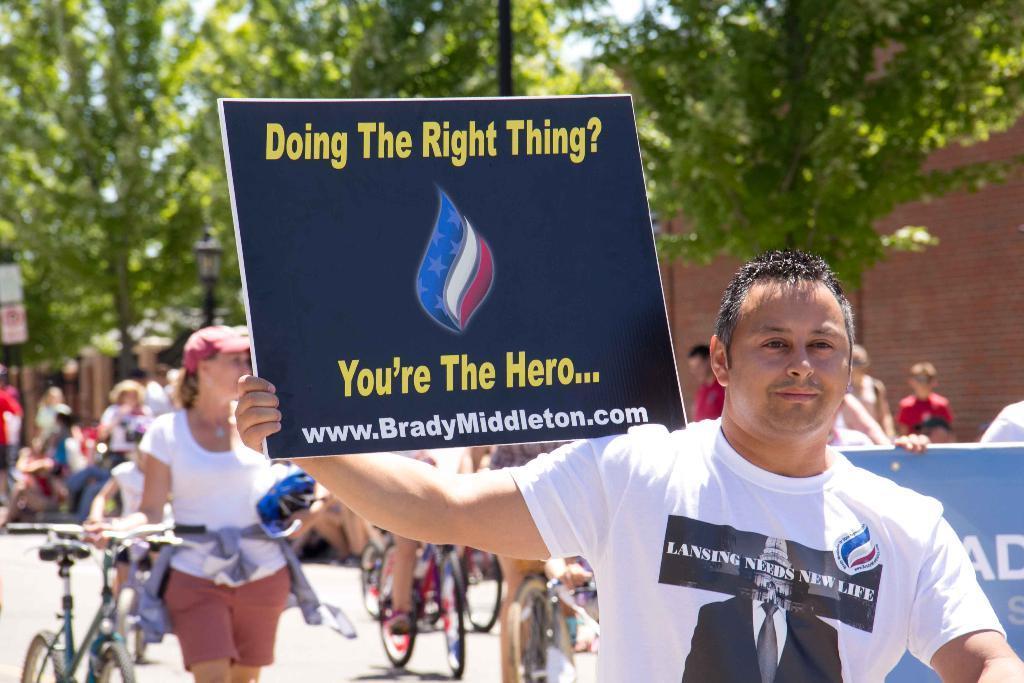How would you summarize this image in a sentence or two? In this image in front there are two people holding the placards. Behind them there are a few people cycling on the road. In the background of the image there are people sitting on the road. There are are trees. There is a street light. There is a wall. 